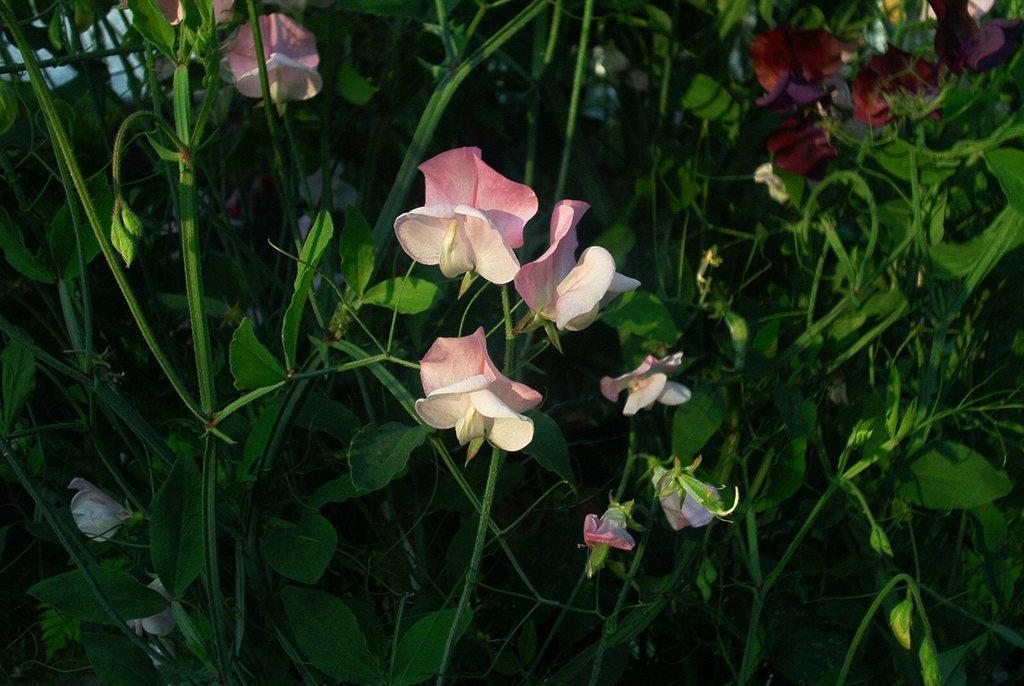Please provide a concise description of this image. In this picture we can see flowers and in the background we can see plants. 